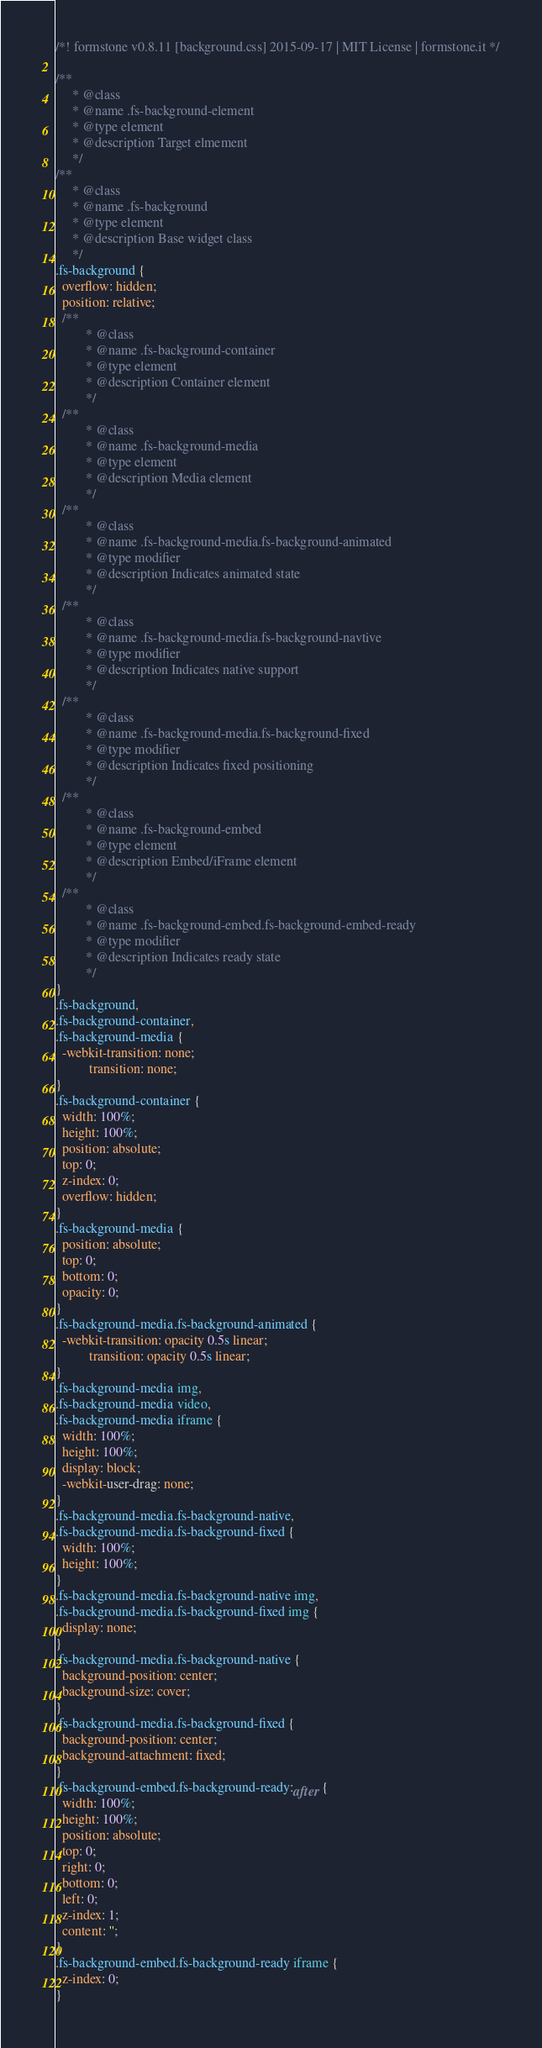<code> <loc_0><loc_0><loc_500><loc_500><_CSS_>/*! formstone v0.8.11 [background.css] 2015-09-17 | MIT License | formstone.it */

/**
	 * @class
	 * @name .fs-background-element
	 * @type element
	 * @description Target elmement
	 */
/**
	 * @class
	 * @name .fs-background
	 * @type element
	 * @description Base widget class
	 */
.fs-background {
  overflow: hidden;
  position: relative;
  /**
		 * @class
		 * @name .fs-background-container
		 * @type element
		 * @description Container element
		 */
  /**
		 * @class
		 * @name .fs-background-media
		 * @type element
		 * @description Media element
		 */
  /**
		 * @class
		 * @name .fs-background-media.fs-background-animated
		 * @type modifier
		 * @description Indicates animated state
		 */
  /**
		 * @class
		 * @name .fs-background-media.fs-background-navtive
		 * @type modifier
		 * @description Indicates native support
		 */
  /**
		 * @class
		 * @name .fs-background-media.fs-background-fixed
		 * @type modifier
		 * @description Indicates fixed positioning
		 */
  /**
		 * @class
		 * @name .fs-background-embed
		 * @type element
		 * @description Embed/iFrame element
		 */
  /**
		 * @class
		 * @name .fs-background-embed.fs-background-embed-ready
		 * @type modifier
		 * @description Indicates ready state
		 */
}
.fs-background,
.fs-background-container,
.fs-background-media {
  -webkit-transition: none;
          transition: none;
}
.fs-background-container {
  width: 100%;
  height: 100%;
  position: absolute;
  top: 0;
  z-index: 0;
  overflow: hidden;
}
.fs-background-media {
  position: absolute;
  top: 0;
  bottom: 0;
  opacity: 0;
}
.fs-background-media.fs-background-animated {
  -webkit-transition: opacity 0.5s linear;
          transition: opacity 0.5s linear;
}
.fs-background-media img,
.fs-background-media video,
.fs-background-media iframe {
  width: 100%;
  height: 100%;
  display: block;
  -webkit-user-drag: none;
}
.fs-background-media.fs-background-native,
.fs-background-media.fs-background-fixed {
  width: 100%;
  height: 100%;
}
.fs-background-media.fs-background-native img,
.fs-background-media.fs-background-fixed img {
  display: none;
}
.fs-background-media.fs-background-native {
  background-position: center;
  background-size: cover;
}
.fs-background-media.fs-background-fixed {
  background-position: center;
  background-attachment: fixed;
}
.fs-background-embed.fs-background-ready:after {
  width: 100%;
  height: 100%;
  position: absolute;
  top: 0;
  right: 0;
  bottom: 0;
  left: 0;
  z-index: 1;
  content: '';
}
.fs-background-embed.fs-background-ready iframe {
  z-index: 0;
}
</code> 